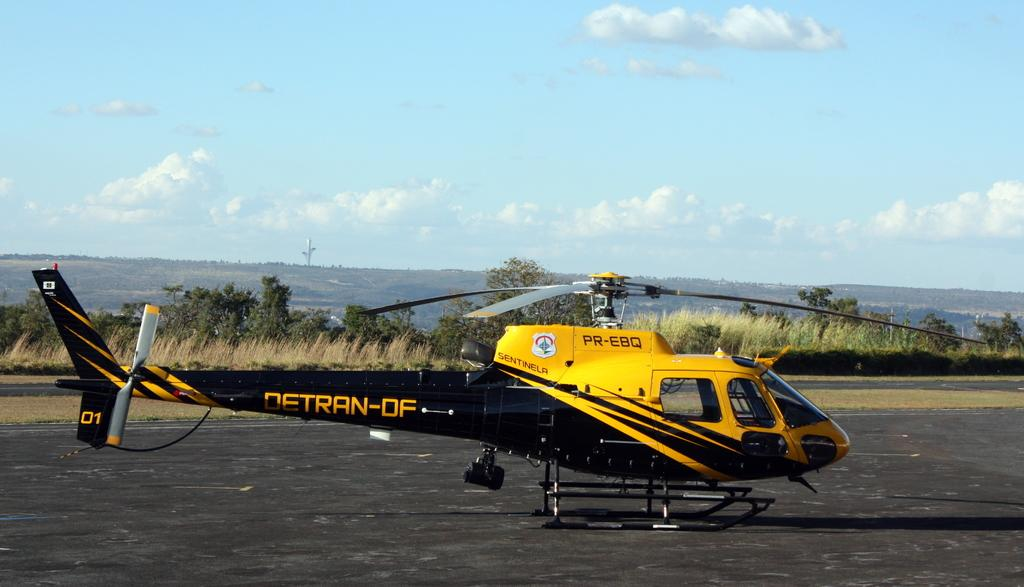<image>
Summarize the visual content of the image. A helicopter with PR-EBQ written on the top. 